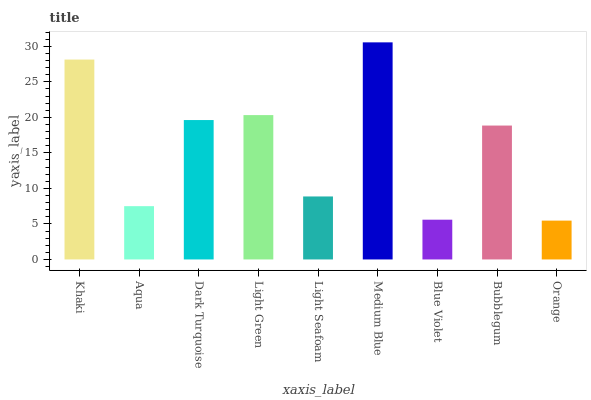Is Orange the minimum?
Answer yes or no. Yes. Is Medium Blue the maximum?
Answer yes or no. Yes. Is Aqua the minimum?
Answer yes or no. No. Is Aqua the maximum?
Answer yes or no. No. Is Khaki greater than Aqua?
Answer yes or no. Yes. Is Aqua less than Khaki?
Answer yes or no. Yes. Is Aqua greater than Khaki?
Answer yes or no. No. Is Khaki less than Aqua?
Answer yes or no. No. Is Bubblegum the high median?
Answer yes or no. Yes. Is Bubblegum the low median?
Answer yes or no. Yes. Is Light Green the high median?
Answer yes or no. No. Is Dark Turquoise the low median?
Answer yes or no. No. 